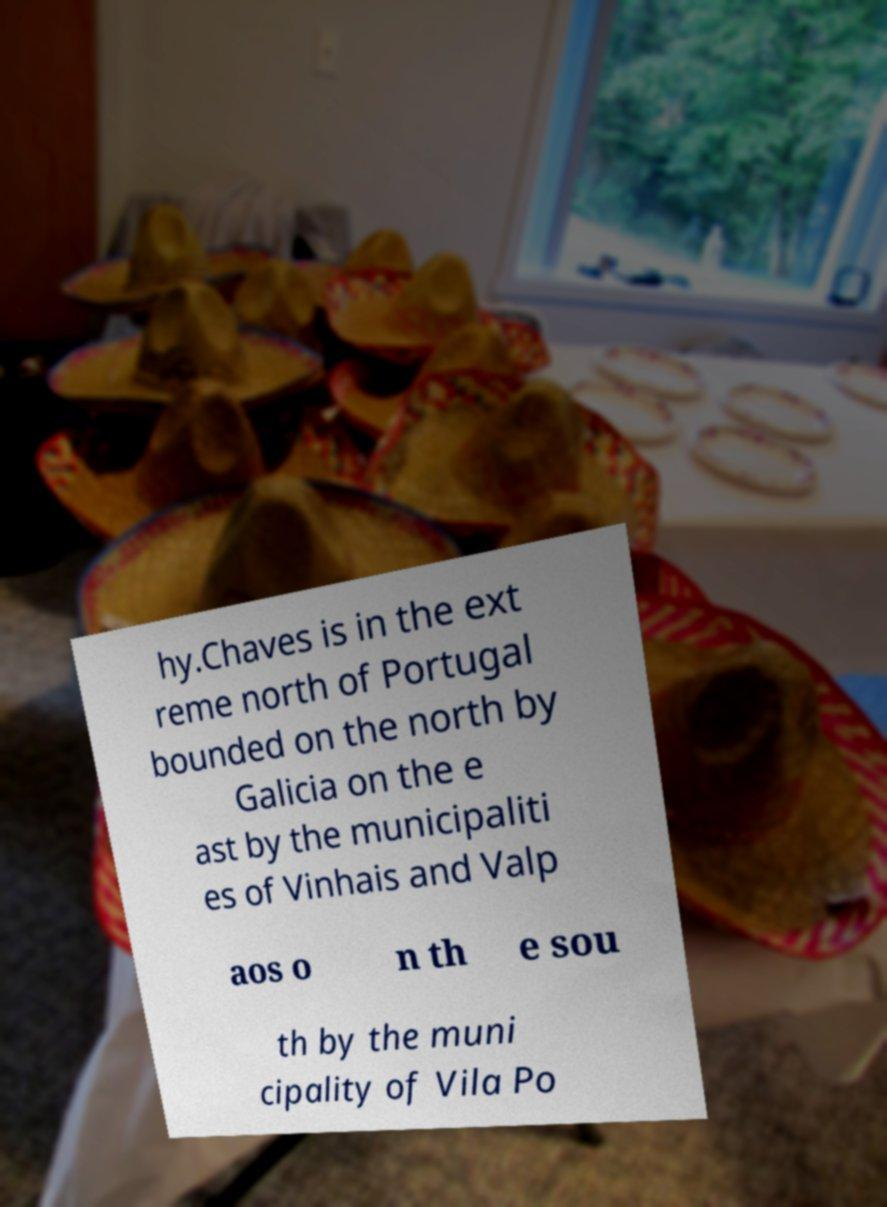For documentation purposes, I need the text within this image transcribed. Could you provide that? hy.Chaves is in the ext reme north of Portugal bounded on the north by Galicia on the e ast by the municipaliti es of Vinhais and Valp aos o n th e sou th by the muni cipality of Vila Po 